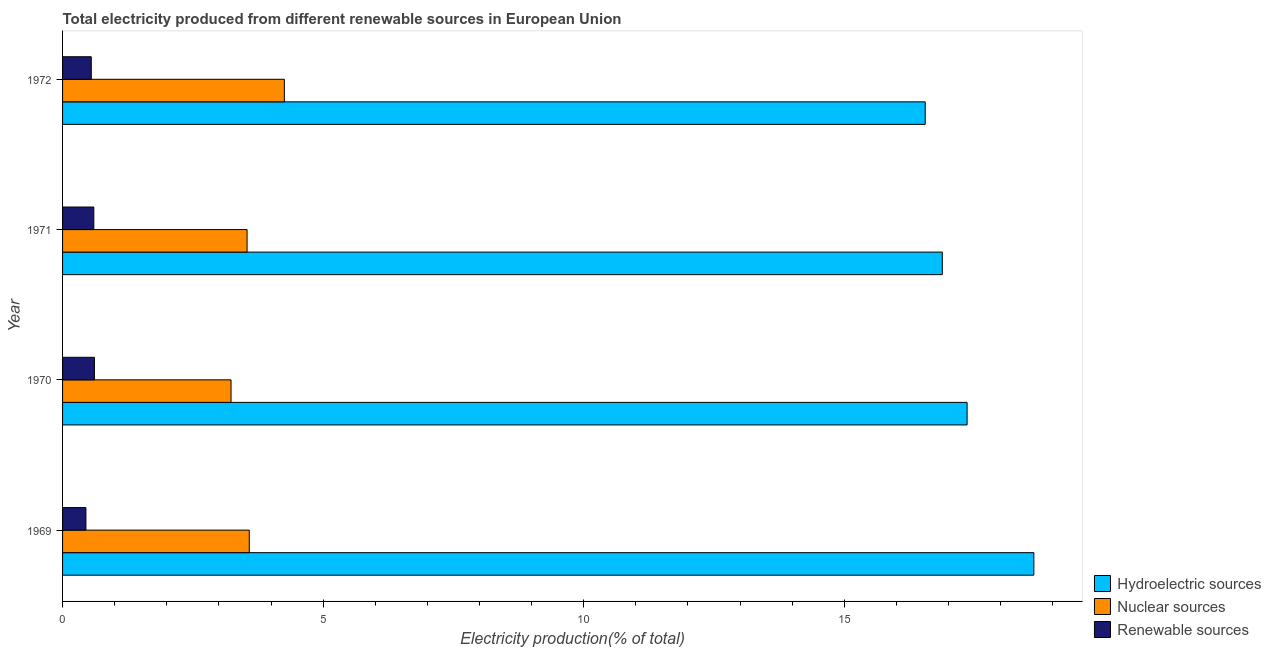How many groups of bars are there?
Provide a short and direct response. 4. Are the number of bars on each tick of the Y-axis equal?
Give a very brief answer. Yes. How many bars are there on the 2nd tick from the top?
Provide a succinct answer. 3. What is the label of the 4th group of bars from the top?
Ensure brevity in your answer.  1969. In how many cases, is the number of bars for a given year not equal to the number of legend labels?
Your answer should be compact. 0. What is the percentage of electricity produced by nuclear sources in 1972?
Provide a short and direct response. 4.26. Across all years, what is the maximum percentage of electricity produced by nuclear sources?
Your response must be concise. 4.26. Across all years, what is the minimum percentage of electricity produced by hydroelectric sources?
Keep it short and to the point. 16.55. In which year was the percentage of electricity produced by nuclear sources maximum?
Offer a very short reply. 1972. In which year was the percentage of electricity produced by renewable sources minimum?
Make the answer very short. 1969. What is the total percentage of electricity produced by nuclear sources in the graph?
Offer a very short reply. 14.61. What is the difference between the percentage of electricity produced by hydroelectric sources in 1970 and that in 1972?
Provide a short and direct response. 0.8. What is the difference between the percentage of electricity produced by hydroelectric sources in 1970 and the percentage of electricity produced by renewable sources in 1972?
Provide a succinct answer. 16.81. What is the average percentage of electricity produced by renewable sources per year?
Your answer should be compact. 0.55. In the year 1970, what is the difference between the percentage of electricity produced by nuclear sources and percentage of electricity produced by renewable sources?
Provide a succinct answer. 2.62. What is the ratio of the percentage of electricity produced by renewable sources in 1970 to that in 1971?
Provide a succinct answer. 1.02. Is the percentage of electricity produced by hydroelectric sources in 1970 less than that in 1972?
Make the answer very short. No. What is the difference between the highest and the second highest percentage of electricity produced by renewable sources?
Make the answer very short. 0.01. What is the difference between the highest and the lowest percentage of electricity produced by hydroelectric sources?
Your response must be concise. 2.08. What does the 3rd bar from the top in 1971 represents?
Keep it short and to the point. Hydroelectric sources. What does the 3rd bar from the bottom in 1970 represents?
Your answer should be very brief. Renewable sources. Is it the case that in every year, the sum of the percentage of electricity produced by hydroelectric sources and percentage of electricity produced by nuclear sources is greater than the percentage of electricity produced by renewable sources?
Offer a terse response. Yes. How many bars are there?
Give a very brief answer. 12. How many years are there in the graph?
Keep it short and to the point. 4. What is the difference between two consecutive major ticks on the X-axis?
Your answer should be very brief. 5. Are the values on the major ticks of X-axis written in scientific E-notation?
Keep it short and to the point. No. Does the graph contain grids?
Keep it short and to the point. No. How many legend labels are there?
Offer a very short reply. 3. What is the title of the graph?
Provide a succinct answer. Total electricity produced from different renewable sources in European Union. Does "Spain" appear as one of the legend labels in the graph?
Give a very brief answer. No. What is the label or title of the X-axis?
Keep it short and to the point. Electricity production(% of total). What is the Electricity production(% of total) in Hydroelectric sources in 1969?
Give a very brief answer. 18.64. What is the Electricity production(% of total) of Nuclear sources in 1969?
Provide a short and direct response. 3.58. What is the Electricity production(% of total) of Renewable sources in 1969?
Provide a succinct answer. 0.45. What is the Electricity production(% of total) in Hydroelectric sources in 1970?
Provide a short and direct response. 17.36. What is the Electricity production(% of total) in Nuclear sources in 1970?
Offer a very short reply. 3.23. What is the Electricity production(% of total) of Renewable sources in 1970?
Your answer should be very brief. 0.61. What is the Electricity production(% of total) in Hydroelectric sources in 1971?
Offer a very short reply. 16.88. What is the Electricity production(% of total) of Nuclear sources in 1971?
Give a very brief answer. 3.54. What is the Electricity production(% of total) of Renewable sources in 1971?
Provide a short and direct response. 0.6. What is the Electricity production(% of total) in Hydroelectric sources in 1972?
Keep it short and to the point. 16.55. What is the Electricity production(% of total) in Nuclear sources in 1972?
Offer a very short reply. 4.26. What is the Electricity production(% of total) in Renewable sources in 1972?
Your answer should be compact. 0.55. Across all years, what is the maximum Electricity production(% of total) of Hydroelectric sources?
Give a very brief answer. 18.64. Across all years, what is the maximum Electricity production(% of total) in Nuclear sources?
Your answer should be compact. 4.26. Across all years, what is the maximum Electricity production(% of total) of Renewable sources?
Ensure brevity in your answer.  0.61. Across all years, what is the minimum Electricity production(% of total) in Hydroelectric sources?
Your answer should be compact. 16.55. Across all years, what is the minimum Electricity production(% of total) in Nuclear sources?
Provide a short and direct response. 3.23. Across all years, what is the minimum Electricity production(% of total) in Renewable sources?
Keep it short and to the point. 0.45. What is the total Electricity production(% of total) in Hydroelectric sources in the graph?
Provide a succinct answer. 69.43. What is the total Electricity production(% of total) of Nuclear sources in the graph?
Offer a very short reply. 14.61. What is the total Electricity production(% of total) in Renewable sources in the graph?
Keep it short and to the point. 2.21. What is the difference between the Electricity production(% of total) of Hydroelectric sources in 1969 and that in 1970?
Your answer should be very brief. 1.28. What is the difference between the Electricity production(% of total) in Nuclear sources in 1969 and that in 1970?
Offer a very short reply. 0.35. What is the difference between the Electricity production(% of total) of Renewable sources in 1969 and that in 1970?
Offer a very short reply. -0.16. What is the difference between the Electricity production(% of total) in Hydroelectric sources in 1969 and that in 1971?
Your response must be concise. 1.76. What is the difference between the Electricity production(% of total) of Nuclear sources in 1969 and that in 1971?
Your answer should be very brief. 0.04. What is the difference between the Electricity production(% of total) in Renewable sources in 1969 and that in 1971?
Keep it short and to the point. -0.15. What is the difference between the Electricity production(% of total) of Hydroelectric sources in 1969 and that in 1972?
Make the answer very short. 2.08. What is the difference between the Electricity production(% of total) of Nuclear sources in 1969 and that in 1972?
Your response must be concise. -0.67. What is the difference between the Electricity production(% of total) of Renewable sources in 1969 and that in 1972?
Ensure brevity in your answer.  -0.1. What is the difference between the Electricity production(% of total) in Hydroelectric sources in 1970 and that in 1971?
Keep it short and to the point. 0.48. What is the difference between the Electricity production(% of total) of Nuclear sources in 1970 and that in 1971?
Provide a succinct answer. -0.31. What is the difference between the Electricity production(% of total) of Renewable sources in 1970 and that in 1971?
Provide a succinct answer. 0.01. What is the difference between the Electricity production(% of total) in Hydroelectric sources in 1970 and that in 1972?
Your response must be concise. 0.8. What is the difference between the Electricity production(% of total) of Nuclear sources in 1970 and that in 1972?
Provide a short and direct response. -1.02. What is the difference between the Electricity production(% of total) in Renewable sources in 1970 and that in 1972?
Your answer should be compact. 0.06. What is the difference between the Electricity production(% of total) of Hydroelectric sources in 1971 and that in 1972?
Offer a very short reply. 0.33. What is the difference between the Electricity production(% of total) in Nuclear sources in 1971 and that in 1972?
Your response must be concise. -0.72. What is the difference between the Electricity production(% of total) of Renewable sources in 1971 and that in 1972?
Ensure brevity in your answer.  0.05. What is the difference between the Electricity production(% of total) in Hydroelectric sources in 1969 and the Electricity production(% of total) in Nuclear sources in 1970?
Your answer should be very brief. 15.4. What is the difference between the Electricity production(% of total) of Hydroelectric sources in 1969 and the Electricity production(% of total) of Renewable sources in 1970?
Your answer should be very brief. 18.03. What is the difference between the Electricity production(% of total) of Nuclear sources in 1969 and the Electricity production(% of total) of Renewable sources in 1970?
Your answer should be very brief. 2.97. What is the difference between the Electricity production(% of total) in Hydroelectric sources in 1969 and the Electricity production(% of total) in Nuclear sources in 1971?
Make the answer very short. 15.1. What is the difference between the Electricity production(% of total) in Hydroelectric sources in 1969 and the Electricity production(% of total) in Renewable sources in 1971?
Provide a succinct answer. 18.04. What is the difference between the Electricity production(% of total) of Nuclear sources in 1969 and the Electricity production(% of total) of Renewable sources in 1971?
Your response must be concise. 2.98. What is the difference between the Electricity production(% of total) in Hydroelectric sources in 1969 and the Electricity production(% of total) in Nuclear sources in 1972?
Keep it short and to the point. 14.38. What is the difference between the Electricity production(% of total) of Hydroelectric sources in 1969 and the Electricity production(% of total) of Renewable sources in 1972?
Your answer should be compact. 18.09. What is the difference between the Electricity production(% of total) of Nuclear sources in 1969 and the Electricity production(% of total) of Renewable sources in 1972?
Make the answer very short. 3.03. What is the difference between the Electricity production(% of total) of Hydroelectric sources in 1970 and the Electricity production(% of total) of Nuclear sources in 1971?
Your answer should be compact. 13.82. What is the difference between the Electricity production(% of total) of Hydroelectric sources in 1970 and the Electricity production(% of total) of Renewable sources in 1971?
Offer a very short reply. 16.76. What is the difference between the Electricity production(% of total) in Nuclear sources in 1970 and the Electricity production(% of total) in Renewable sources in 1971?
Ensure brevity in your answer.  2.63. What is the difference between the Electricity production(% of total) in Hydroelectric sources in 1970 and the Electricity production(% of total) in Nuclear sources in 1972?
Make the answer very short. 13.1. What is the difference between the Electricity production(% of total) of Hydroelectric sources in 1970 and the Electricity production(% of total) of Renewable sources in 1972?
Provide a short and direct response. 16.8. What is the difference between the Electricity production(% of total) of Nuclear sources in 1970 and the Electricity production(% of total) of Renewable sources in 1972?
Provide a short and direct response. 2.68. What is the difference between the Electricity production(% of total) of Hydroelectric sources in 1971 and the Electricity production(% of total) of Nuclear sources in 1972?
Ensure brevity in your answer.  12.62. What is the difference between the Electricity production(% of total) in Hydroelectric sources in 1971 and the Electricity production(% of total) in Renewable sources in 1972?
Your answer should be compact. 16.33. What is the difference between the Electricity production(% of total) in Nuclear sources in 1971 and the Electricity production(% of total) in Renewable sources in 1972?
Your answer should be very brief. 2.99. What is the average Electricity production(% of total) of Hydroelectric sources per year?
Give a very brief answer. 17.36. What is the average Electricity production(% of total) of Nuclear sources per year?
Provide a short and direct response. 3.65. What is the average Electricity production(% of total) of Renewable sources per year?
Provide a succinct answer. 0.55. In the year 1969, what is the difference between the Electricity production(% of total) in Hydroelectric sources and Electricity production(% of total) in Nuclear sources?
Your answer should be compact. 15.05. In the year 1969, what is the difference between the Electricity production(% of total) of Hydroelectric sources and Electricity production(% of total) of Renewable sources?
Give a very brief answer. 18.19. In the year 1969, what is the difference between the Electricity production(% of total) of Nuclear sources and Electricity production(% of total) of Renewable sources?
Your answer should be compact. 3.13. In the year 1970, what is the difference between the Electricity production(% of total) of Hydroelectric sources and Electricity production(% of total) of Nuclear sources?
Make the answer very short. 14.12. In the year 1970, what is the difference between the Electricity production(% of total) of Hydroelectric sources and Electricity production(% of total) of Renewable sources?
Give a very brief answer. 16.74. In the year 1970, what is the difference between the Electricity production(% of total) in Nuclear sources and Electricity production(% of total) in Renewable sources?
Provide a short and direct response. 2.62. In the year 1971, what is the difference between the Electricity production(% of total) in Hydroelectric sources and Electricity production(% of total) in Nuclear sources?
Ensure brevity in your answer.  13.34. In the year 1971, what is the difference between the Electricity production(% of total) of Hydroelectric sources and Electricity production(% of total) of Renewable sources?
Provide a short and direct response. 16.28. In the year 1971, what is the difference between the Electricity production(% of total) of Nuclear sources and Electricity production(% of total) of Renewable sources?
Give a very brief answer. 2.94. In the year 1972, what is the difference between the Electricity production(% of total) in Hydroelectric sources and Electricity production(% of total) in Nuclear sources?
Your answer should be compact. 12.3. In the year 1972, what is the difference between the Electricity production(% of total) of Hydroelectric sources and Electricity production(% of total) of Renewable sources?
Make the answer very short. 16. In the year 1972, what is the difference between the Electricity production(% of total) of Nuclear sources and Electricity production(% of total) of Renewable sources?
Make the answer very short. 3.7. What is the ratio of the Electricity production(% of total) in Hydroelectric sources in 1969 to that in 1970?
Keep it short and to the point. 1.07. What is the ratio of the Electricity production(% of total) of Nuclear sources in 1969 to that in 1970?
Ensure brevity in your answer.  1.11. What is the ratio of the Electricity production(% of total) in Renewable sources in 1969 to that in 1970?
Keep it short and to the point. 0.73. What is the ratio of the Electricity production(% of total) of Hydroelectric sources in 1969 to that in 1971?
Keep it short and to the point. 1.1. What is the ratio of the Electricity production(% of total) in Nuclear sources in 1969 to that in 1971?
Offer a terse response. 1.01. What is the ratio of the Electricity production(% of total) in Renewable sources in 1969 to that in 1971?
Offer a terse response. 0.75. What is the ratio of the Electricity production(% of total) in Hydroelectric sources in 1969 to that in 1972?
Offer a very short reply. 1.13. What is the ratio of the Electricity production(% of total) of Nuclear sources in 1969 to that in 1972?
Provide a succinct answer. 0.84. What is the ratio of the Electricity production(% of total) in Renewable sources in 1969 to that in 1972?
Offer a terse response. 0.81. What is the ratio of the Electricity production(% of total) of Hydroelectric sources in 1970 to that in 1971?
Make the answer very short. 1.03. What is the ratio of the Electricity production(% of total) in Renewable sources in 1970 to that in 1971?
Provide a succinct answer. 1.02. What is the ratio of the Electricity production(% of total) of Hydroelectric sources in 1970 to that in 1972?
Keep it short and to the point. 1.05. What is the ratio of the Electricity production(% of total) in Nuclear sources in 1970 to that in 1972?
Offer a very short reply. 0.76. What is the ratio of the Electricity production(% of total) in Renewable sources in 1970 to that in 1972?
Offer a very short reply. 1.11. What is the ratio of the Electricity production(% of total) in Hydroelectric sources in 1971 to that in 1972?
Ensure brevity in your answer.  1.02. What is the ratio of the Electricity production(% of total) of Nuclear sources in 1971 to that in 1972?
Provide a short and direct response. 0.83. What is the ratio of the Electricity production(% of total) of Renewable sources in 1971 to that in 1972?
Provide a short and direct response. 1.09. What is the difference between the highest and the second highest Electricity production(% of total) of Hydroelectric sources?
Your response must be concise. 1.28. What is the difference between the highest and the second highest Electricity production(% of total) of Nuclear sources?
Give a very brief answer. 0.67. What is the difference between the highest and the second highest Electricity production(% of total) of Renewable sources?
Ensure brevity in your answer.  0.01. What is the difference between the highest and the lowest Electricity production(% of total) of Hydroelectric sources?
Your answer should be very brief. 2.08. What is the difference between the highest and the lowest Electricity production(% of total) in Nuclear sources?
Offer a terse response. 1.02. What is the difference between the highest and the lowest Electricity production(% of total) of Renewable sources?
Offer a very short reply. 0.16. 